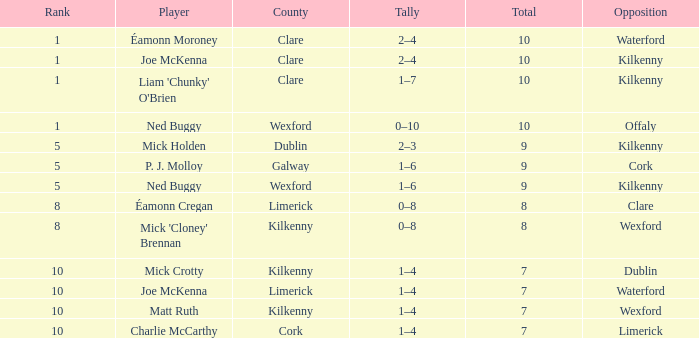In which county is there a rank above 8, and a player called joe mckenna? Limerick. Write the full table. {'header': ['Rank', 'Player', 'County', 'Tally', 'Total', 'Opposition'], 'rows': [['1', 'Éamonn Moroney', 'Clare', '2–4', '10', 'Waterford'], ['1', 'Joe McKenna', 'Clare', '2–4', '10', 'Kilkenny'], ['1', "Liam 'Chunky' O'Brien", 'Clare', '1–7', '10', 'Kilkenny'], ['1', 'Ned Buggy', 'Wexford', '0–10', '10', 'Offaly'], ['5', 'Mick Holden', 'Dublin', '2–3', '9', 'Kilkenny'], ['5', 'P. J. Molloy', 'Galway', '1–6', '9', 'Cork'], ['5', 'Ned Buggy', 'Wexford', '1–6', '9', 'Kilkenny'], ['8', 'Éamonn Cregan', 'Limerick', '0–8', '8', 'Clare'], ['8', "Mick 'Cloney' Brennan", 'Kilkenny', '0–8', '8', 'Wexford'], ['10', 'Mick Crotty', 'Kilkenny', '1–4', '7', 'Dublin'], ['10', 'Joe McKenna', 'Limerick', '1–4', '7', 'Waterford'], ['10', 'Matt Ruth', 'Kilkenny', '1–4', '7', 'Wexford'], ['10', 'Charlie McCarthy', 'Cork', '1–4', '7', 'Limerick']]} 